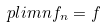<formula> <loc_0><loc_0><loc_500><loc_500>\ p l i m n f _ { n } = f</formula> 